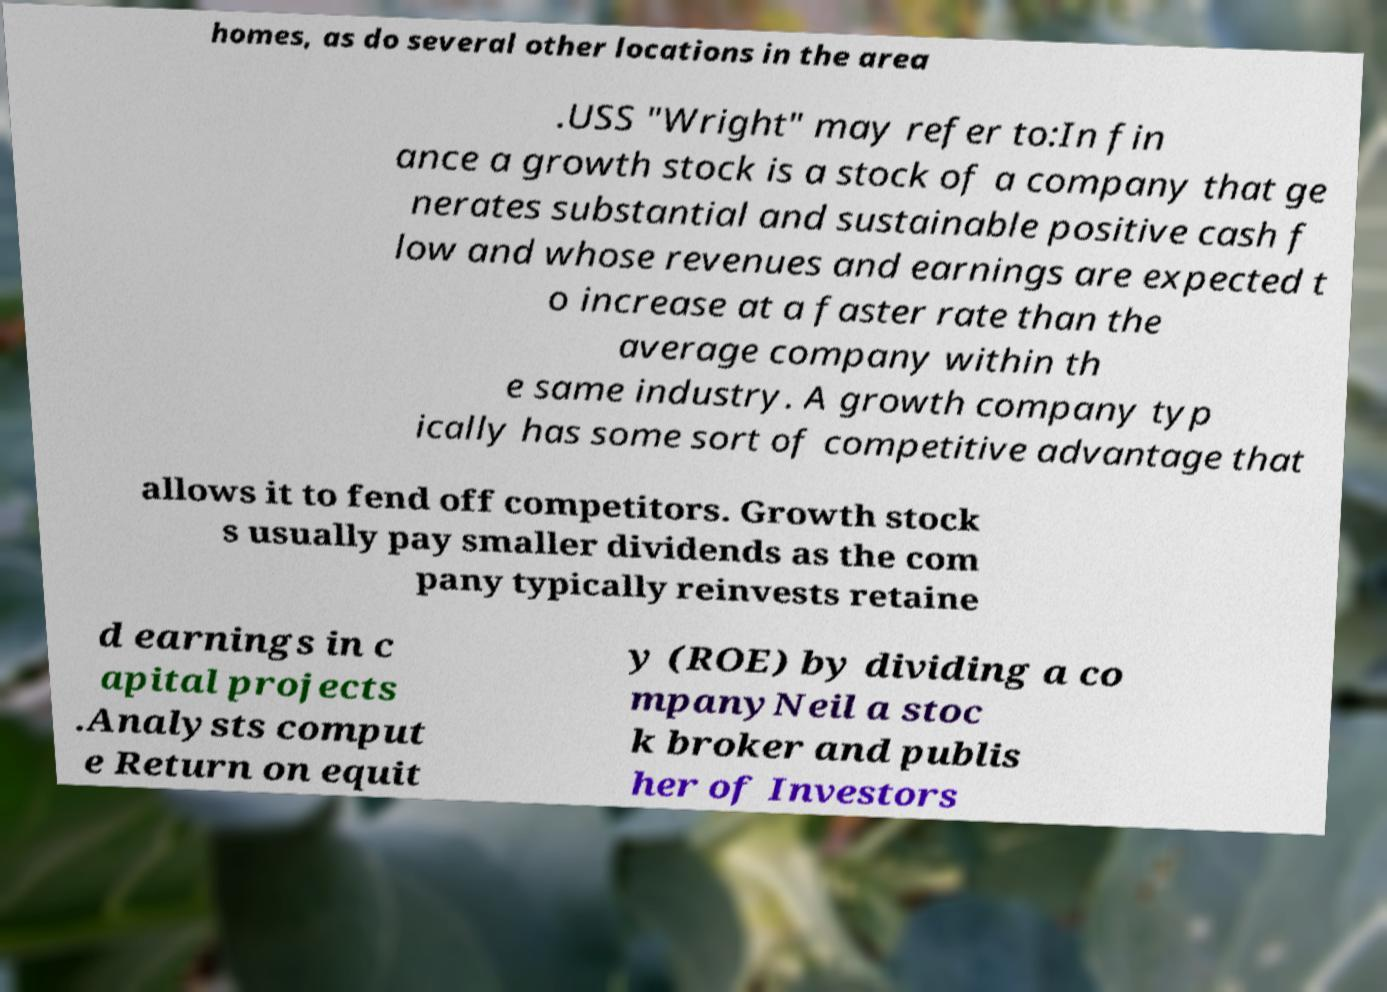Can you read and provide the text displayed in the image?This photo seems to have some interesting text. Can you extract and type it out for me? homes, as do several other locations in the area .USS "Wright" may refer to:In fin ance a growth stock is a stock of a company that ge nerates substantial and sustainable positive cash f low and whose revenues and earnings are expected t o increase at a faster rate than the average company within th e same industry. A growth company typ ically has some sort of competitive advantage that allows it to fend off competitors. Growth stock s usually pay smaller dividends as the com pany typically reinvests retaine d earnings in c apital projects .Analysts comput e Return on equit y (ROE) by dividing a co mpanyNeil a stoc k broker and publis her of Investors 